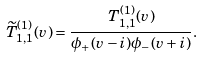<formula> <loc_0><loc_0><loc_500><loc_500>\widetilde { T } _ { 1 , 1 } ^ { ( 1 ) } ( v ) = \frac { T _ { 1 , 1 } ^ { ( 1 ) } ( v ) } { \phi _ { + } ( v - i ) \phi _ { - } ( v + i ) } .</formula> 